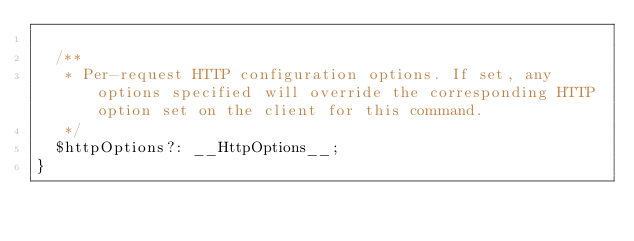<code> <loc_0><loc_0><loc_500><loc_500><_TypeScript_>
  /**
   * Per-request HTTP configuration options. If set, any options specified will override the corresponding HTTP option set on the client for this command.
   */
  $httpOptions?: __HttpOptions__;
}
</code> 